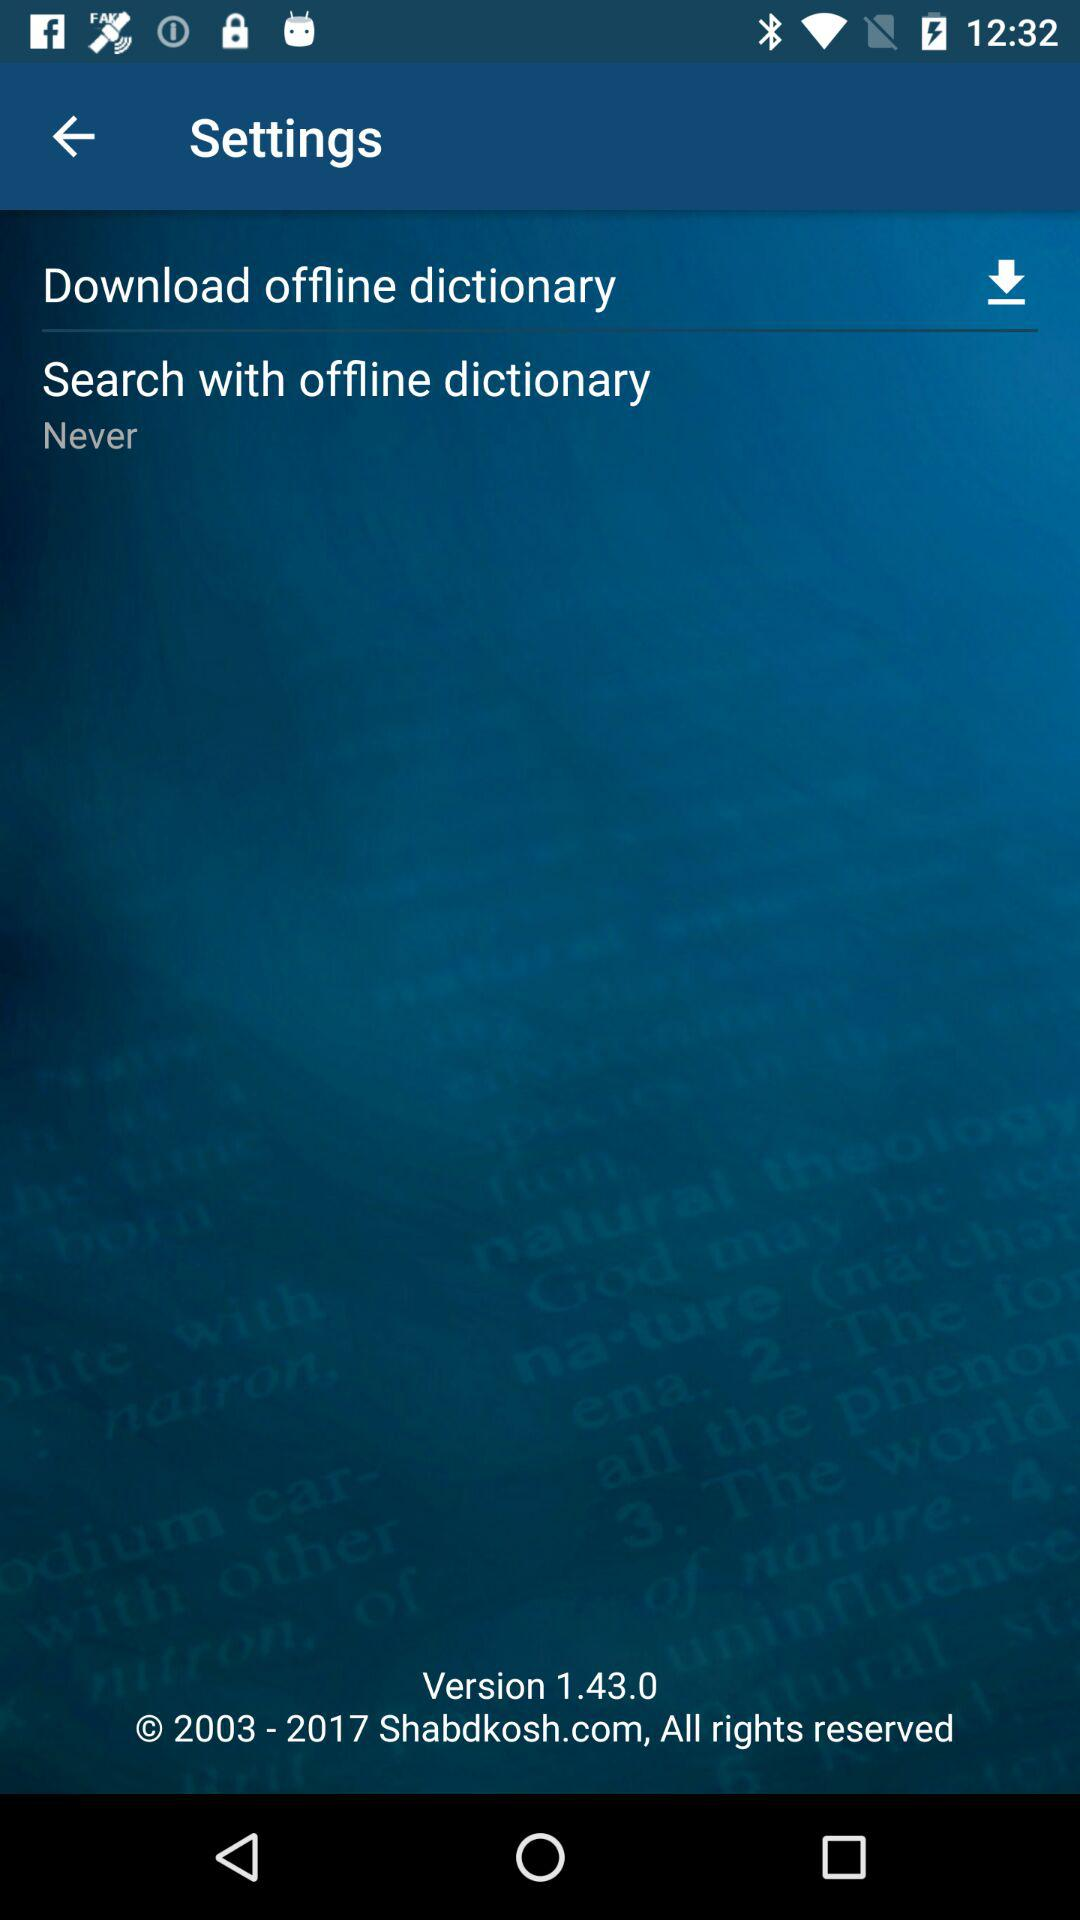How many options are there to search with offline dictionary?
Answer the question using a single word or phrase. 2 